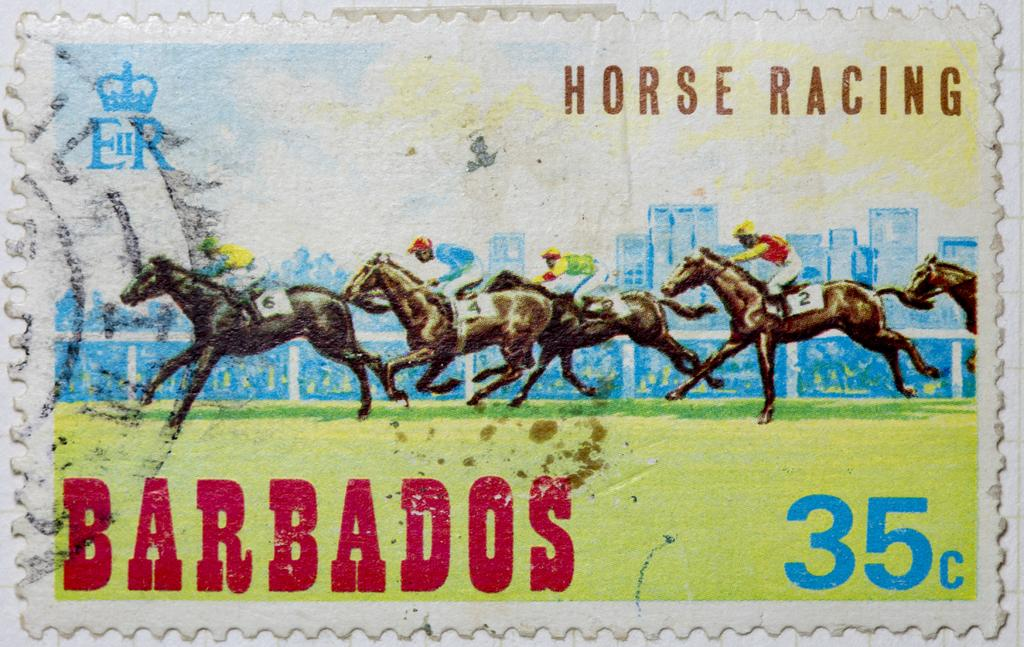What is the main subject of the image? There is a painting in the image. What is happening in the painting? The painting depicts people sitting on horses. Are there any additional details on the painting? Yes, there are names written on the painting. What is the size of the father in the image? There is no father present in the image; it features a painting of people sitting on horses. 